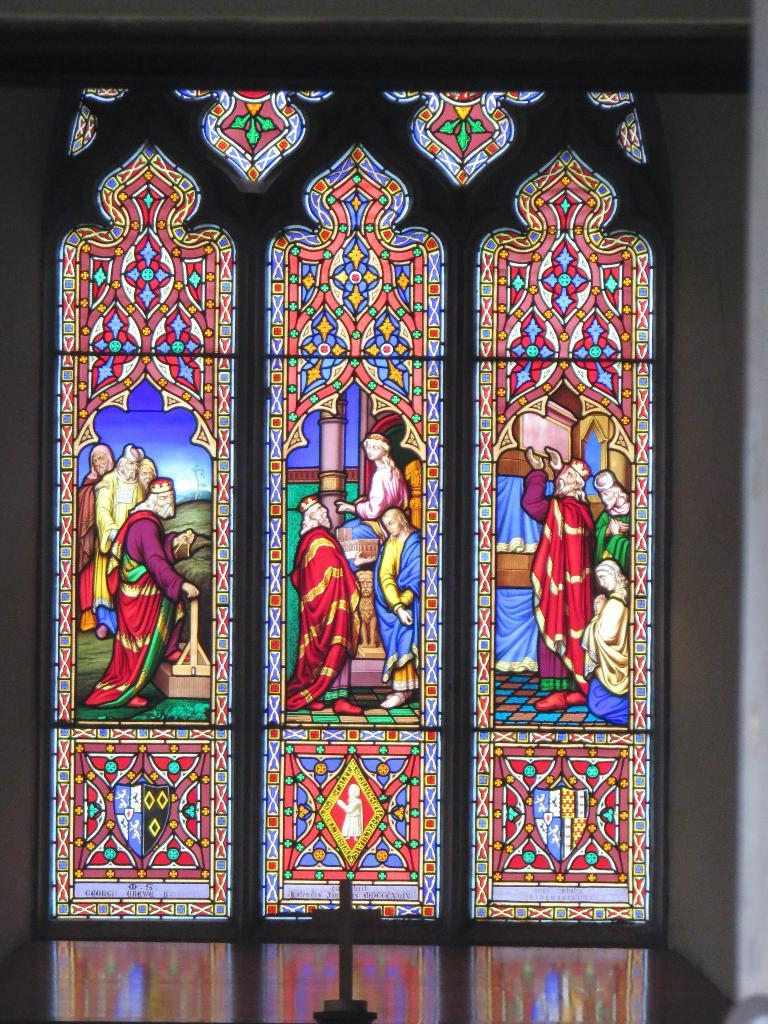What type of wall is present in the image? There is a glass wall in the image. What can be seen on the glass wall? Paintings are visible on the glass wall. What note is being played by the leg in the image? There is no leg or note being played in the image; it only features a glass wall with paintings on it. 